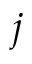<formula> <loc_0><loc_0><loc_500><loc_500>j</formula> 